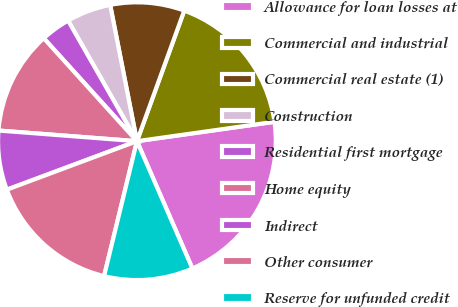Convert chart to OTSL. <chart><loc_0><loc_0><loc_500><loc_500><pie_chart><fcel>Allowance for loan losses at<fcel>Commercial and industrial<fcel>Commercial real estate (1)<fcel>Construction<fcel>Residential first mortgage<fcel>Home equity<fcel>Indirect<fcel>Other consumer<fcel>Reserve for unfunded credit<nl><fcel>20.69%<fcel>17.24%<fcel>8.62%<fcel>5.17%<fcel>3.45%<fcel>12.07%<fcel>6.9%<fcel>15.52%<fcel>10.34%<nl></chart> 